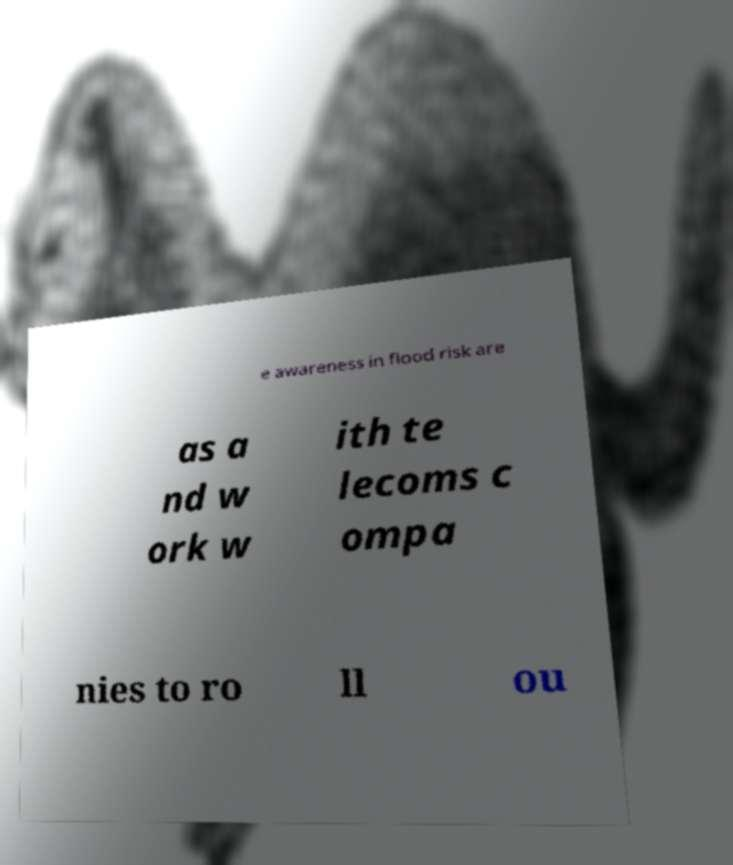Please read and relay the text visible in this image. What does it say? e awareness in flood risk are as a nd w ork w ith te lecoms c ompa nies to ro ll ou 